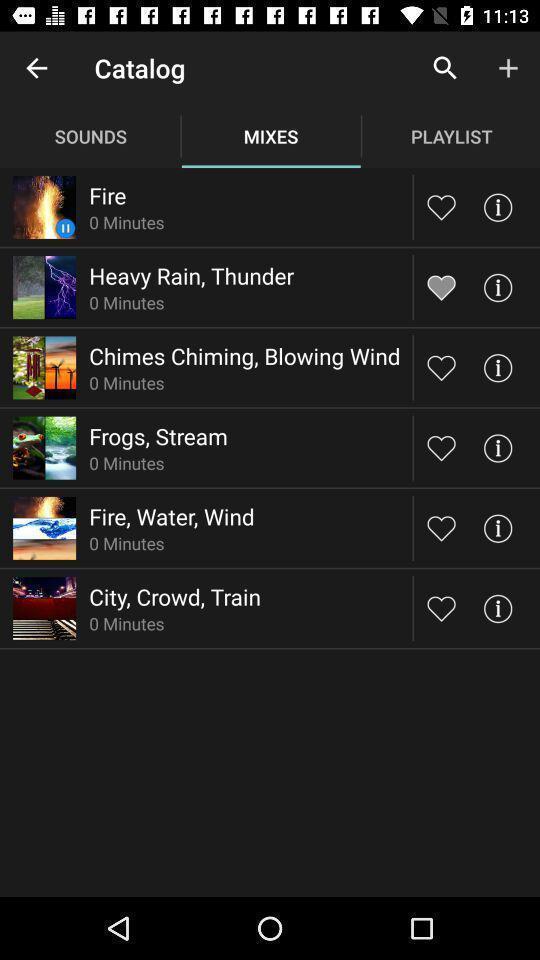Tell me about the visual elements in this screen capture. Page showing list of mixes with multiple options and icons. 